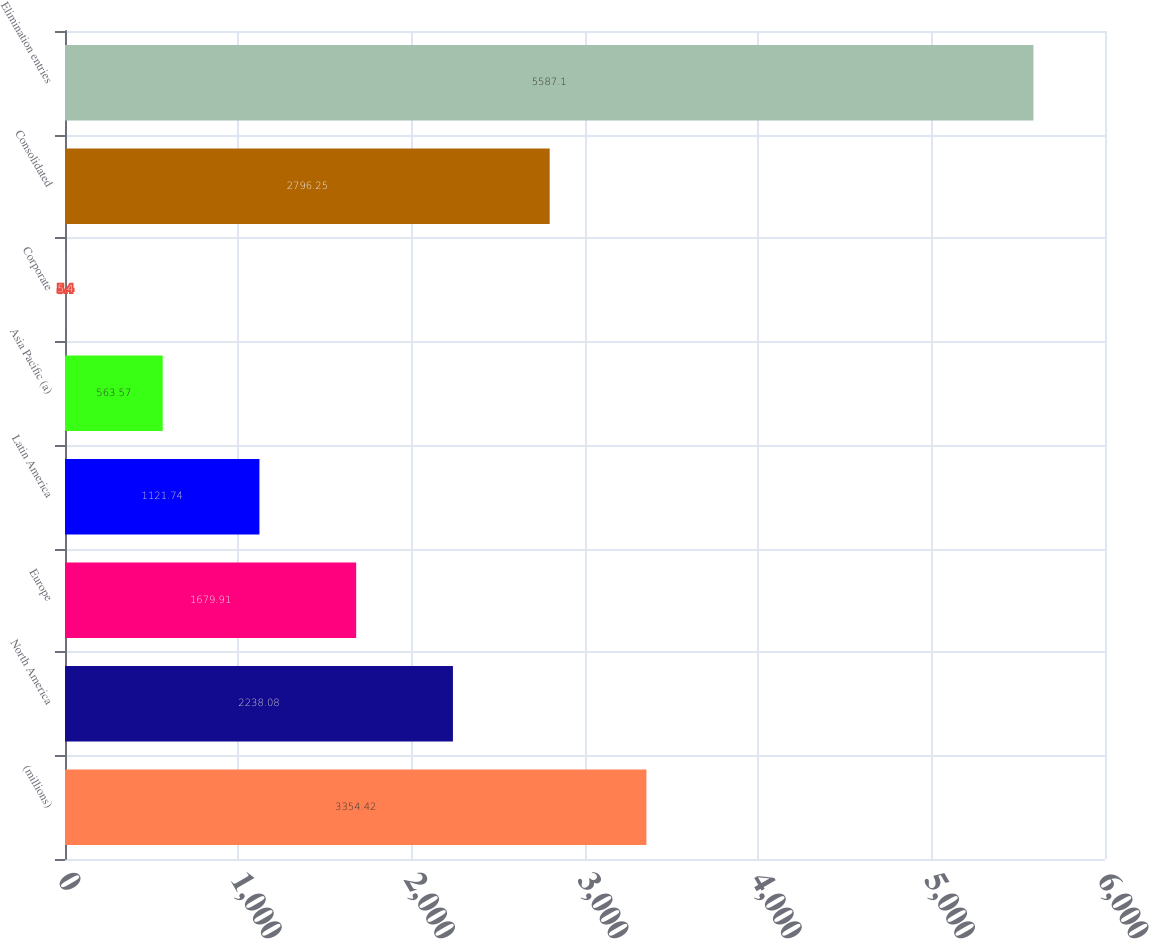<chart> <loc_0><loc_0><loc_500><loc_500><bar_chart><fcel>(millions)<fcel>North America<fcel>Europe<fcel>Latin America<fcel>Asia Pacific (a)<fcel>Corporate<fcel>Consolidated<fcel>Elimination entries<nl><fcel>3354.42<fcel>2238.08<fcel>1679.91<fcel>1121.74<fcel>563.57<fcel>5.4<fcel>2796.25<fcel>5587.1<nl></chart> 